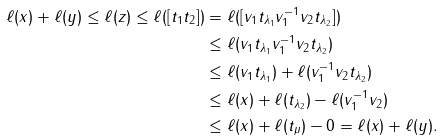Convert formula to latex. <formula><loc_0><loc_0><loc_500><loc_500>\ell ( x ) + \ell ( y ) \leq \ell ( z ) \leq \ell ( [ t _ { 1 } t _ { 2 } ] ) & = \ell ( [ v _ { 1 } t _ { \lambda _ { 1 } } v _ { 1 } ^ { - 1 } v _ { 2 } t _ { \lambda _ { 2 } } ] ) \\ & \leq \ell ( v _ { 1 } t _ { \lambda _ { 1 } } v _ { 1 } ^ { - 1 } v _ { 2 } t _ { \lambda _ { 2 } } ) \\ & \leq \ell ( v _ { 1 } t _ { \lambda _ { 1 } } ) + \ell ( v _ { 1 } ^ { - 1 } v _ { 2 } t _ { \lambda _ { 2 } } ) \\ & \leq \ell ( x ) + \ell ( t _ { \lambda _ { 2 } } ) - \ell ( v _ { 1 } ^ { - 1 } v _ { 2 } ) \\ & \leq \ell ( x ) + \ell ( t _ { \mu } ) - 0 = \ell ( x ) + \ell ( y ) .</formula> 